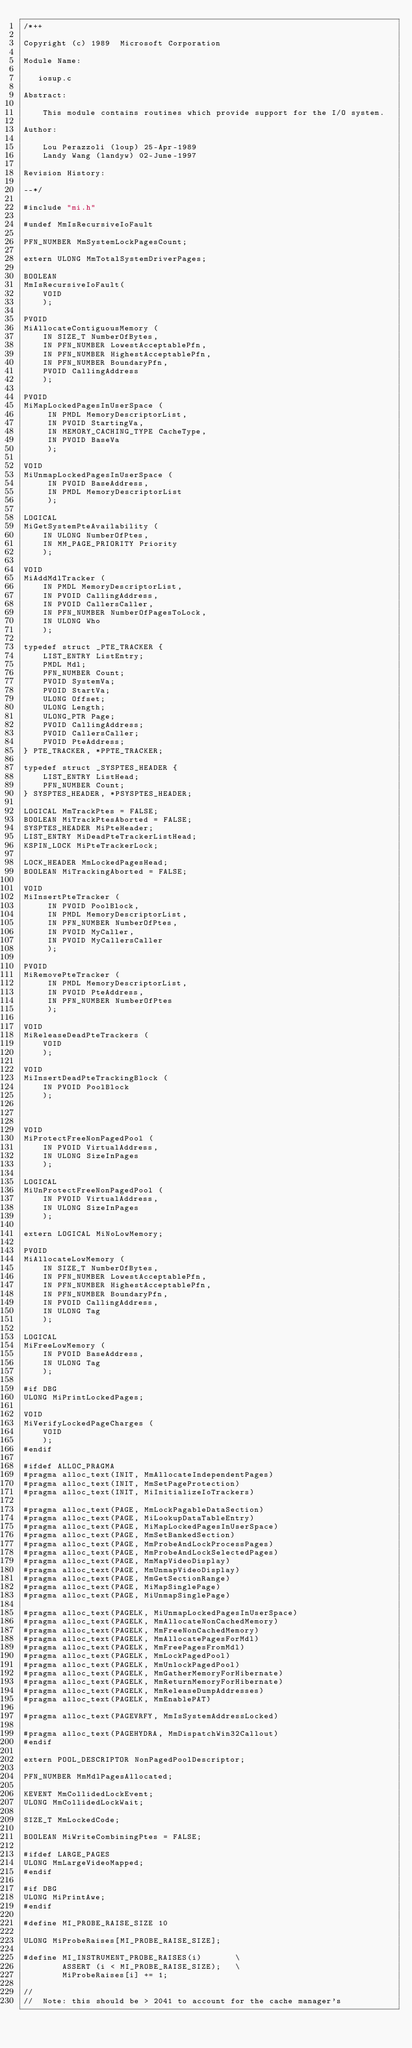Convert code to text. <code><loc_0><loc_0><loc_500><loc_500><_C_>/*++

Copyright (c) 1989  Microsoft Corporation

Module Name:

   iosup.c

Abstract:

    This module contains routines which provide support for the I/O system.

Author:

    Lou Perazzoli (loup) 25-Apr-1989
    Landy Wang (landyw) 02-June-1997

Revision History:

--*/

#include "mi.h"

#undef MmIsRecursiveIoFault

PFN_NUMBER MmSystemLockPagesCount;

extern ULONG MmTotalSystemDriverPages;

BOOLEAN
MmIsRecursiveIoFault(
    VOID
    );

PVOID
MiAllocateContiguousMemory (
    IN SIZE_T NumberOfBytes,
    IN PFN_NUMBER LowestAcceptablePfn,
    IN PFN_NUMBER HighestAcceptablePfn,
    IN PFN_NUMBER BoundaryPfn,
    PVOID CallingAddress
    );

PVOID
MiMapLockedPagesInUserSpace (
     IN PMDL MemoryDescriptorList,
     IN PVOID StartingVa,
     IN MEMORY_CACHING_TYPE CacheType,
     IN PVOID BaseVa
     );

VOID
MiUnmapLockedPagesInUserSpace (
     IN PVOID BaseAddress,
     IN PMDL MemoryDescriptorList
     );

LOGICAL
MiGetSystemPteAvailability (
    IN ULONG NumberOfPtes,
    IN MM_PAGE_PRIORITY Priority
    );

VOID
MiAddMdlTracker (
    IN PMDL MemoryDescriptorList,
    IN PVOID CallingAddress,
    IN PVOID CallersCaller,
    IN PFN_NUMBER NumberOfPagesToLock,
    IN ULONG Who
    );

typedef struct _PTE_TRACKER {
    LIST_ENTRY ListEntry;
    PMDL Mdl;
    PFN_NUMBER Count;
    PVOID SystemVa;
    PVOID StartVa;
    ULONG Offset;
    ULONG Length;
    ULONG_PTR Page;
    PVOID CallingAddress;
    PVOID CallersCaller;
    PVOID PteAddress;
} PTE_TRACKER, *PPTE_TRACKER;

typedef struct _SYSPTES_HEADER {
    LIST_ENTRY ListHead;
    PFN_NUMBER Count;
} SYSPTES_HEADER, *PSYSPTES_HEADER;

LOGICAL MmTrackPtes = FALSE;
BOOLEAN MiTrackPtesAborted = FALSE;
SYSPTES_HEADER MiPteHeader;
LIST_ENTRY MiDeadPteTrackerListHead;
KSPIN_LOCK MiPteTrackerLock;

LOCK_HEADER MmLockedPagesHead;
BOOLEAN MiTrackingAborted = FALSE;

VOID
MiInsertPteTracker (
     IN PVOID PoolBlock,
     IN PMDL MemoryDescriptorList,
     IN PFN_NUMBER NumberOfPtes,
     IN PVOID MyCaller,
     IN PVOID MyCallersCaller
     );

PVOID
MiRemovePteTracker (
     IN PMDL MemoryDescriptorList,
     IN PVOID PteAddress,
     IN PFN_NUMBER NumberOfPtes
     );

VOID
MiReleaseDeadPteTrackers (
    VOID
    );

VOID
MiInsertDeadPteTrackingBlock (
    IN PVOID PoolBlock
    );



VOID
MiProtectFreeNonPagedPool (
    IN PVOID VirtualAddress,
    IN ULONG SizeInPages
    );

LOGICAL
MiUnProtectFreeNonPagedPool (
    IN PVOID VirtualAddress,
    IN ULONG SizeInPages
    );

extern LOGICAL MiNoLowMemory;

PVOID
MiAllocateLowMemory (
    IN SIZE_T NumberOfBytes,
    IN PFN_NUMBER LowestAcceptablePfn,
    IN PFN_NUMBER HighestAcceptablePfn,
    IN PFN_NUMBER BoundaryPfn,
    IN PVOID CallingAddress,
    IN ULONG Tag
    );

LOGICAL
MiFreeLowMemory (
    IN PVOID BaseAddress,
    IN ULONG Tag
    );

#if DBG
ULONG MiPrintLockedPages;

VOID
MiVerifyLockedPageCharges (
    VOID
    );
#endif

#ifdef ALLOC_PRAGMA
#pragma alloc_text(INIT, MmAllocateIndependentPages)
#pragma alloc_text(INIT, MmSetPageProtection)
#pragma alloc_text(INIT, MiInitializeIoTrackers)

#pragma alloc_text(PAGE, MmLockPagableDataSection)
#pragma alloc_text(PAGE, MiLookupDataTableEntry)
#pragma alloc_text(PAGE, MiMapLockedPagesInUserSpace)
#pragma alloc_text(PAGE, MmSetBankedSection)
#pragma alloc_text(PAGE, MmProbeAndLockProcessPages)
#pragma alloc_text(PAGE, MmProbeAndLockSelectedPages)
#pragma alloc_text(PAGE, MmMapVideoDisplay)
#pragma alloc_text(PAGE, MmUnmapVideoDisplay)
#pragma alloc_text(PAGE, MmGetSectionRange)
#pragma alloc_text(PAGE, MiMapSinglePage)
#pragma alloc_text(PAGE, MiUnmapSinglePage)

#pragma alloc_text(PAGELK, MiUnmapLockedPagesInUserSpace)
#pragma alloc_text(PAGELK, MmAllocateNonCachedMemory)
#pragma alloc_text(PAGELK, MmFreeNonCachedMemory)
#pragma alloc_text(PAGELK, MmAllocatePagesForMdl)
#pragma alloc_text(PAGELK, MmFreePagesFromMdl)
#pragma alloc_text(PAGELK, MmLockPagedPool)
#pragma alloc_text(PAGELK, MmUnlockPagedPool)
#pragma alloc_text(PAGELK, MmGatherMemoryForHibernate)
#pragma alloc_text(PAGELK, MmReturnMemoryForHibernate)
#pragma alloc_text(PAGELK, MmReleaseDumpAddresses)
#pragma alloc_text(PAGELK, MmEnablePAT)

#pragma alloc_text(PAGEVRFY, MmIsSystemAddressLocked)

#pragma alloc_text(PAGEHYDRA, MmDispatchWin32Callout)
#endif

extern POOL_DESCRIPTOR NonPagedPoolDescriptor;

PFN_NUMBER MmMdlPagesAllocated;

KEVENT MmCollidedLockEvent;
ULONG MmCollidedLockWait;

SIZE_T MmLockedCode;

BOOLEAN MiWriteCombiningPtes = FALSE;

#ifdef LARGE_PAGES
ULONG MmLargeVideoMapped;
#endif

#if DBG
ULONG MiPrintAwe;
#endif

#define MI_PROBE_RAISE_SIZE 10

ULONG MiProbeRaises[MI_PROBE_RAISE_SIZE];

#define MI_INSTRUMENT_PROBE_RAISES(i)       \
        ASSERT (i < MI_PROBE_RAISE_SIZE);   \
        MiProbeRaises[i] += 1;

//
//  Note: this should be > 2041 to account for the cache manager's</code> 